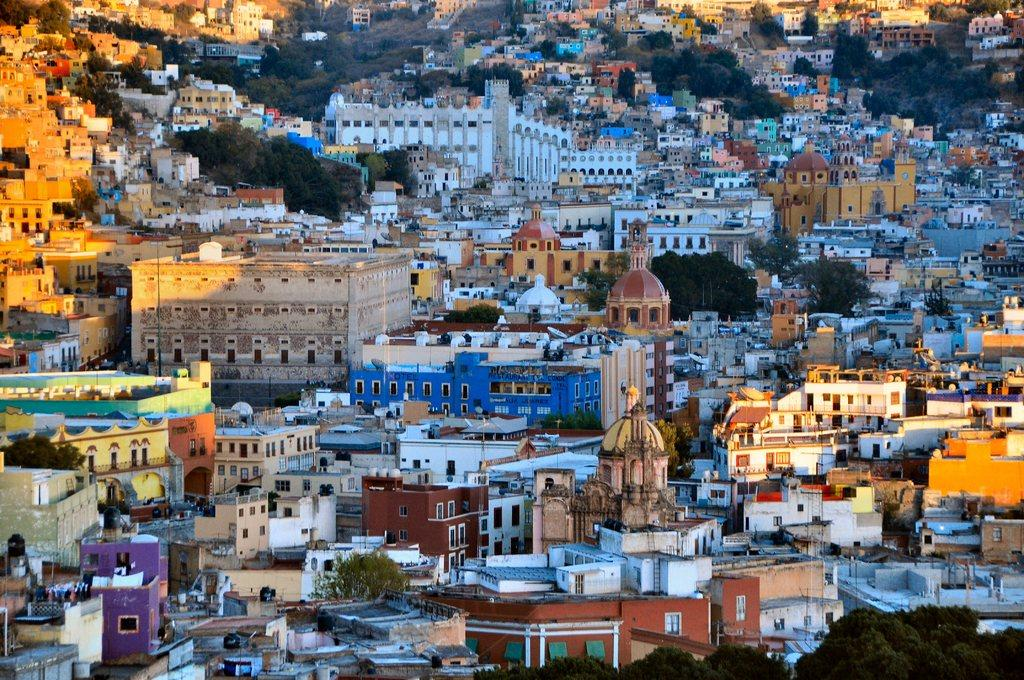What type of view is shown in the image? The image is an aerial view. What structures can be seen from this perspective? There are buildings visible in the image. What natural elements can be seen in the image? There are trees visible in the image. What type of plant is being tasted by the person in the image? There is no person present in the image, and therefore no plant being tasted. 